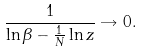<formula> <loc_0><loc_0><loc_500><loc_500>\frac { 1 } { \ln \beta - \frac { 1 } { N } \ln z } \rightarrow 0 .</formula> 